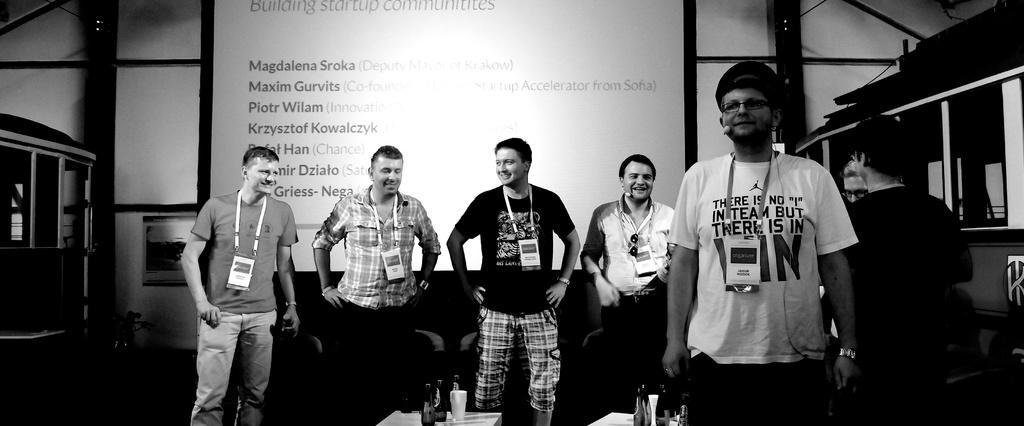Can you describe this image briefly? In this image there are a few people standing with smile on their face, behind them there are chairs. On the left and right side of the image there are objects which are not clear. In the background there is a wall with some text. 